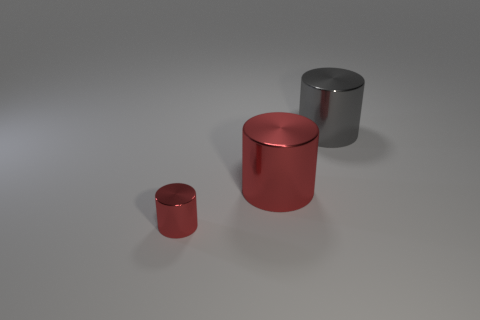What color is the tiny object that is the same shape as the large red thing?
Ensure brevity in your answer.  Red. What number of other big metal objects are the same shape as the large gray thing?
Your answer should be very brief. 1. How many objects are either large gray cylinders or metallic cylinders on the left side of the gray metal thing?
Provide a short and direct response. 3. There is a small shiny object; is its color the same as the big cylinder that is left of the gray object?
Provide a succinct answer. Yes. How big is the object that is both on the right side of the tiny metal thing and to the left of the big gray shiny cylinder?
Your answer should be compact. Large. There is a tiny red object; are there any large metal cylinders right of it?
Your answer should be very brief. Yes. Is there a object to the right of the red shiny cylinder in front of the big red shiny cylinder?
Provide a short and direct response. Yes. Are there an equal number of red metal things that are on the right side of the gray metallic thing and large gray metal things that are left of the large red metallic cylinder?
Keep it short and to the point. Yes. What color is the big cylinder that is the same material as the big red object?
Your answer should be very brief. Gray. Is there another cylinder made of the same material as the tiny cylinder?
Your response must be concise. Yes. 